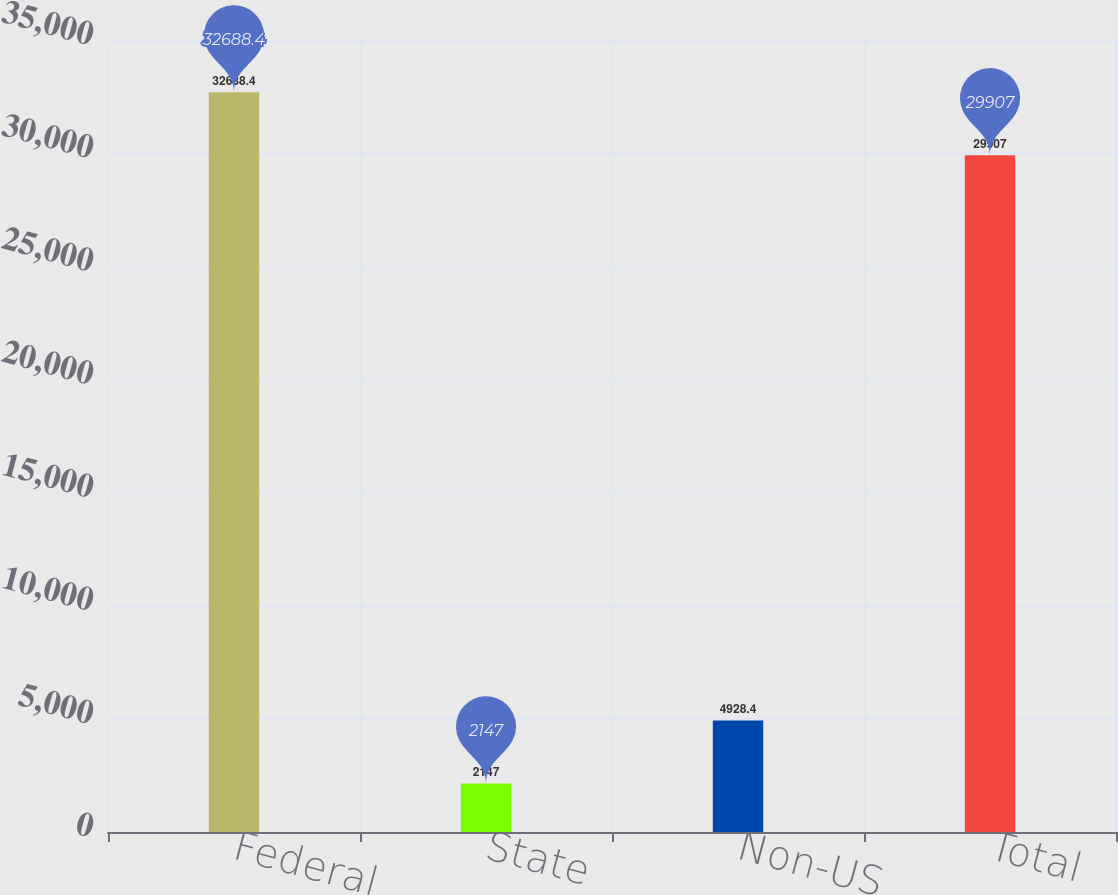<chart> <loc_0><loc_0><loc_500><loc_500><bar_chart><fcel>Federal<fcel>State<fcel>Non-US<fcel>Total<nl><fcel>32688.4<fcel>2147<fcel>4928.4<fcel>29907<nl></chart> 